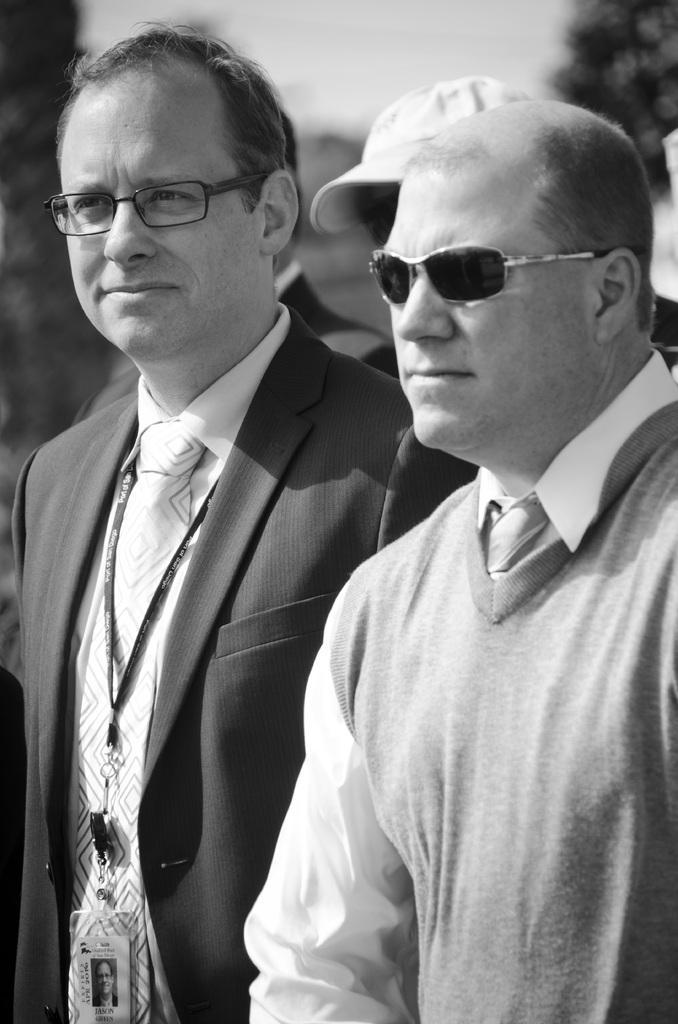Describe this image in one or two sentences. This image is a black and white image. This image is taken outdoors. In the background there are two people. In the middle of the image two men are standing. They have worn spectacles. 